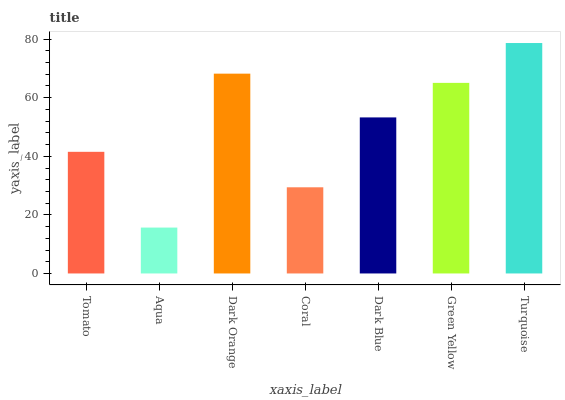Is Aqua the minimum?
Answer yes or no. Yes. Is Turquoise the maximum?
Answer yes or no. Yes. Is Dark Orange the minimum?
Answer yes or no. No. Is Dark Orange the maximum?
Answer yes or no. No. Is Dark Orange greater than Aqua?
Answer yes or no. Yes. Is Aqua less than Dark Orange?
Answer yes or no. Yes. Is Aqua greater than Dark Orange?
Answer yes or no. No. Is Dark Orange less than Aqua?
Answer yes or no. No. Is Dark Blue the high median?
Answer yes or no. Yes. Is Dark Blue the low median?
Answer yes or no. Yes. Is Dark Orange the high median?
Answer yes or no. No. Is Aqua the low median?
Answer yes or no. No. 